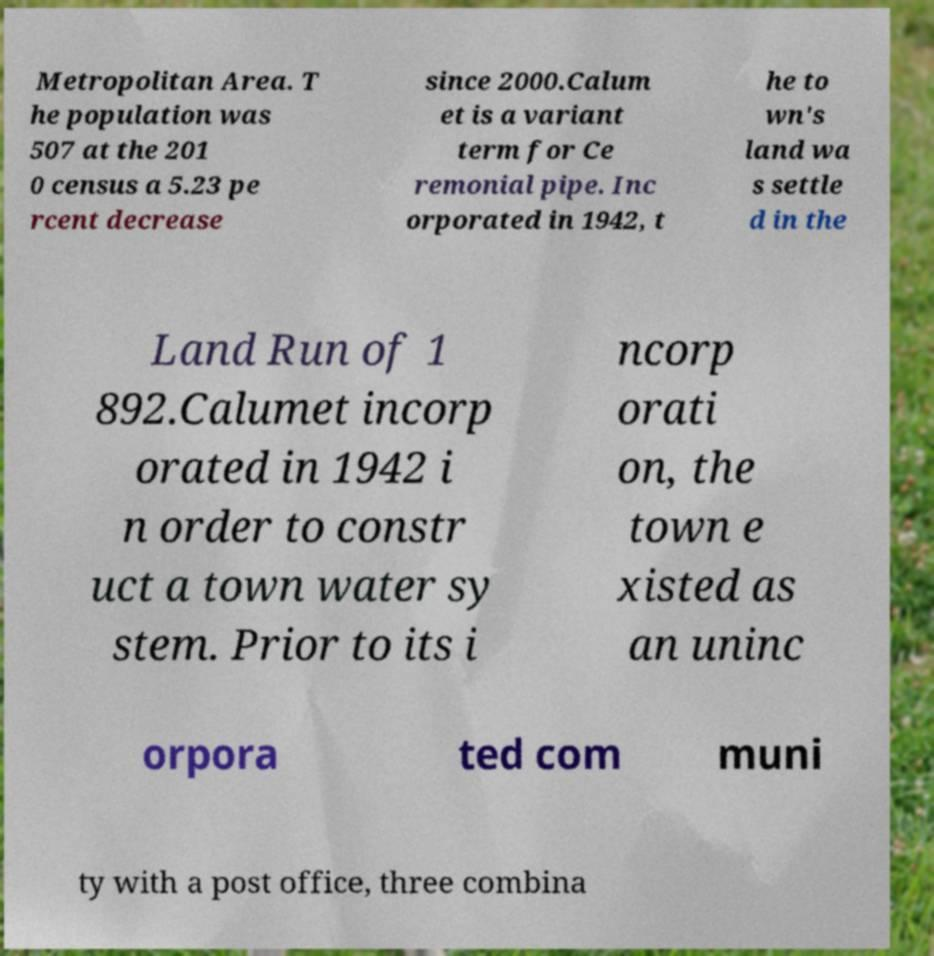For documentation purposes, I need the text within this image transcribed. Could you provide that? Metropolitan Area. T he population was 507 at the 201 0 census a 5.23 pe rcent decrease since 2000.Calum et is a variant term for Ce remonial pipe. Inc orporated in 1942, t he to wn's land wa s settle d in the Land Run of 1 892.Calumet incorp orated in 1942 i n order to constr uct a town water sy stem. Prior to its i ncorp orati on, the town e xisted as an uninc orpora ted com muni ty with a post office, three combina 